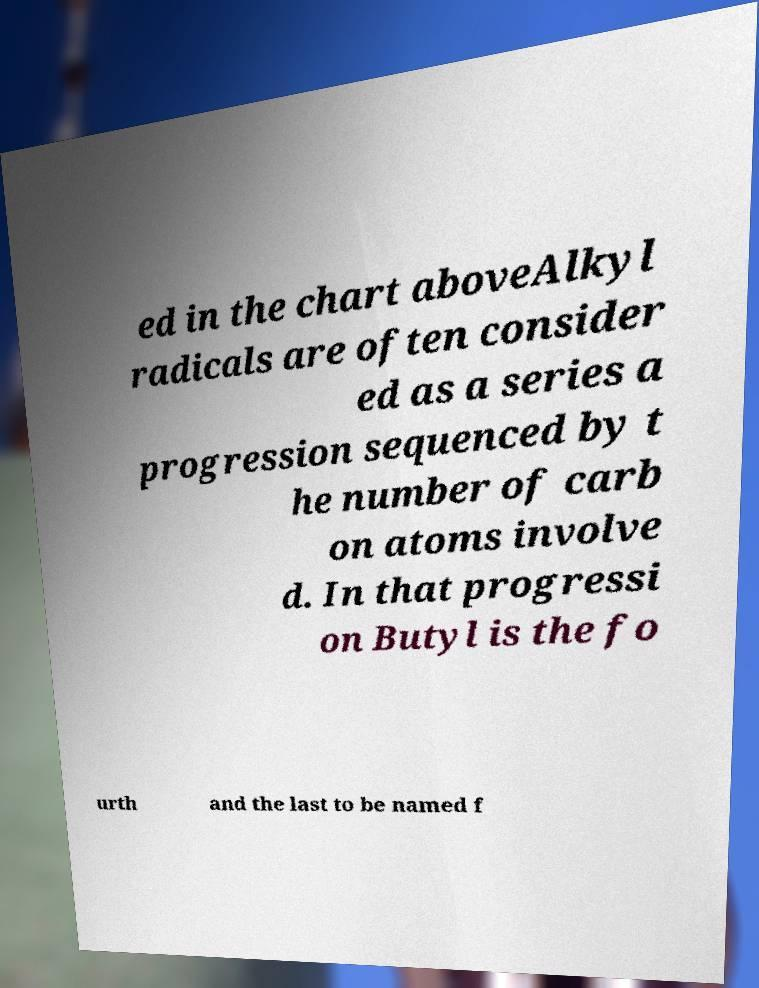There's text embedded in this image that I need extracted. Can you transcribe it verbatim? ed in the chart aboveAlkyl radicals are often consider ed as a series a progression sequenced by t he number of carb on atoms involve d. In that progressi on Butyl is the fo urth and the last to be named f 